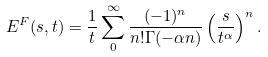<formula> <loc_0><loc_0><loc_500><loc_500>E ^ { F } ( s , t ) = \frac { 1 } { t } \sum _ { 0 } ^ { \infty } \frac { ( - 1 ) ^ { n } } { n ! \Gamma ( - \alpha n ) } \left ( \frac { s } { t ^ { \alpha } } \right ) ^ { n } .</formula> 